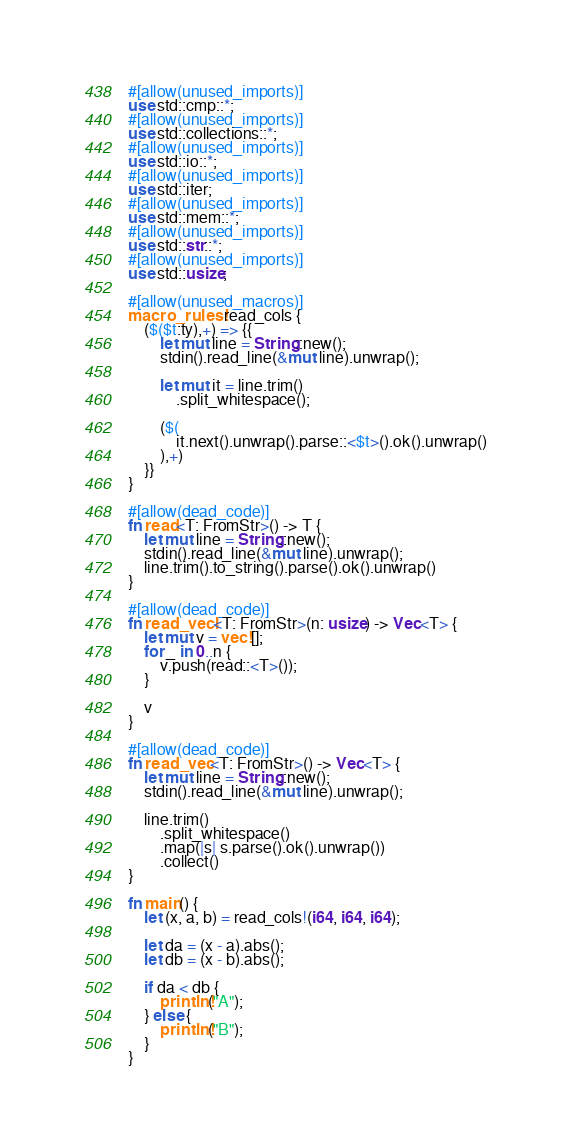<code> <loc_0><loc_0><loc_500><loc_500><_Rust_>#[allow(unused_imports)]
use std::cmp::*;
#[allow(unused_imports)]
use std::collections::*;
#[allow(unused_imports)]
use std::io::*;
#[allow(unused_imports)]
use std::iter;
#[allow(unused_imports)]
use std::mem::*;
#[allow(unused_imports)]
use std::str::*;
#[allow(unused_imports)]
use std::usize;

#[allow(unused_macros)]
macro_rules! read_cols {
    ($($t:ty),+) => {{
        let mut line = String::new();
        stdin().read_line(&mut line).unwrap();

        let mut it = line.trim()
            .split_whitespace();

        ($(
            it.next().unwrap().parse::<$t>().ok().unwrap()
        ),+)
    }}
}

#[allow(dead_code)]
fn read<T: FromStr>() -> T {
    let mut line = String::new();
    stdin().read_line(&mut line).unwrap();
    line.trim().to_string().parse().ok().unwrap()
}

#[allow(dead_code)]
fn read_vecl<T: FromStr>(n: usize) -> Vec<T> {
    let mut v = vec![];
    for _ in 0..n {
        v.push(read::<T>());
    }

    v
}

#[allow(dead_code)]
fn read_vec<T: FromStr>() -> Vec<T> {
    let mut line = String::new();
    stdin().read_line(&mut line).unwrap();

    line.trim()
        .split_whitespace()
        .map(|s| s.parse().ok().unwrap())
        .collect()
}

fn main() {
    let (x, a, b) = read_cols!(i64, i64, i64);

    let da = (x - a).abs();
    let db = (x - b).abs();

    if da < db {
        println!("A");
    } else {
        println!("B");
    }
}
</code> 